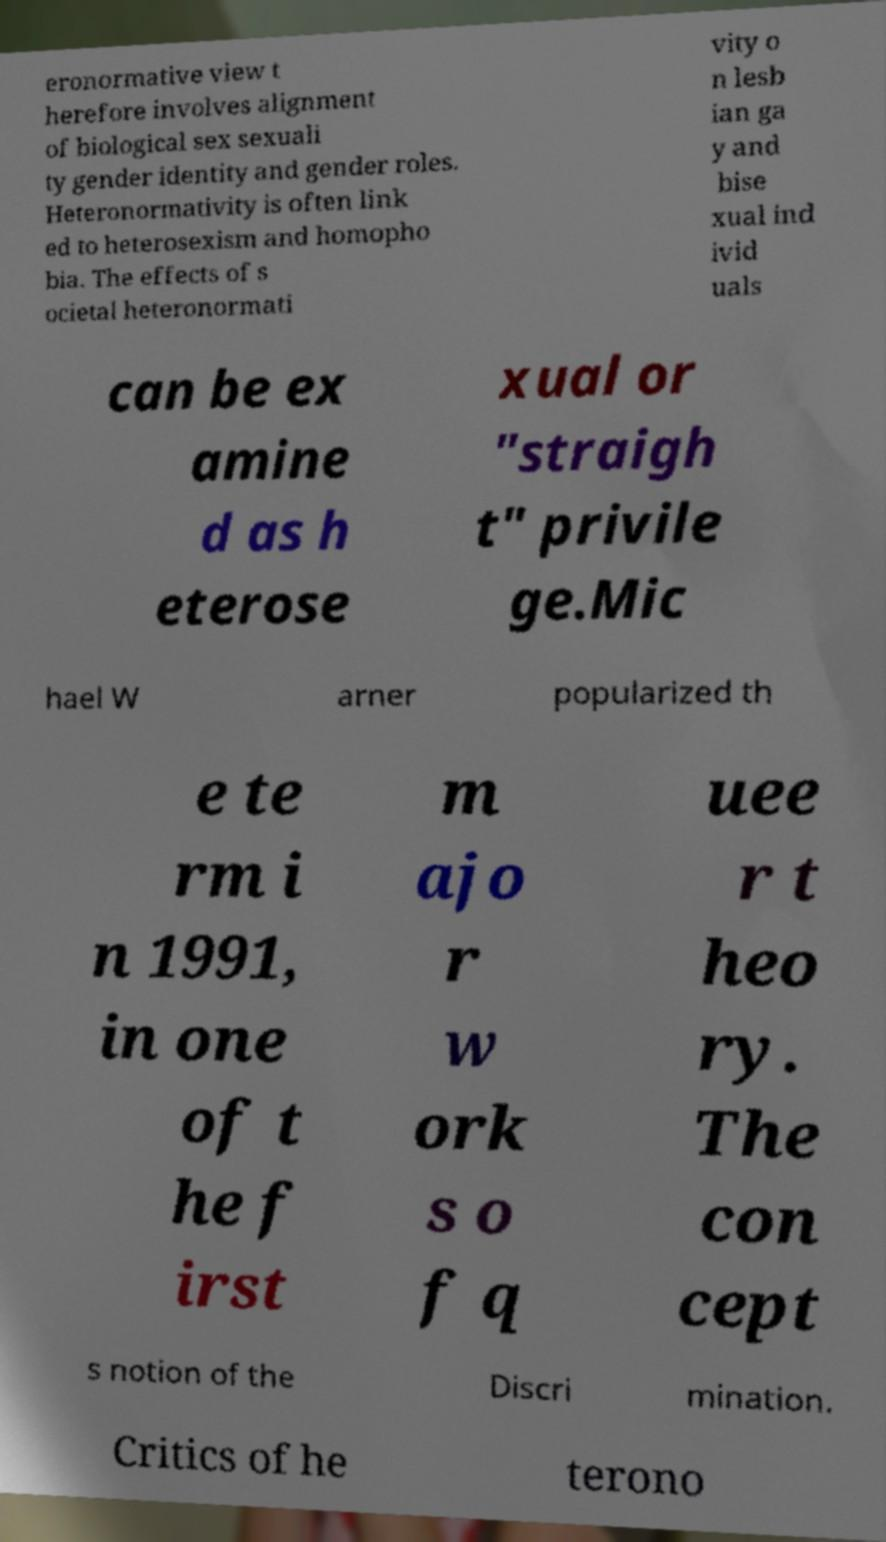What messages or text are displayed in this image? I need them in a readable, typed format. eronormative view t herefore involves alignment of biological sex sexuali ty gender identity and gender roles. Heteronormativity is often link ed to heterosexism and homopho bia. The effects of s ocietal heteronormati vity o n lesb ian ga y and bise xual ind ivid uals can be ex amine d as h eterose xual or "straigh t" privile ge.Mic hael W arner popularized th e te rm i n 1991, in one of t he f irst m ajo r w ork s o f q uee r t heo ry. The con cept s notion of the Discri mination. Critics of he terono 